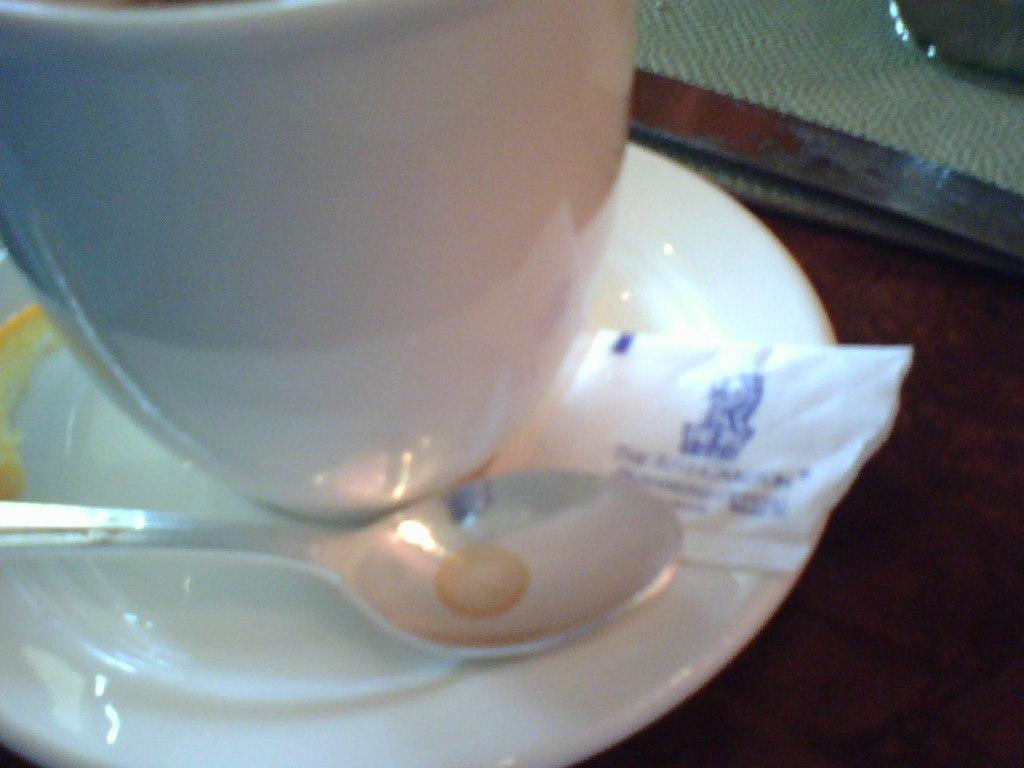Can you describe this image briefly? In the center of the image there is a cup and a saucer on the table. There is a spoon. 